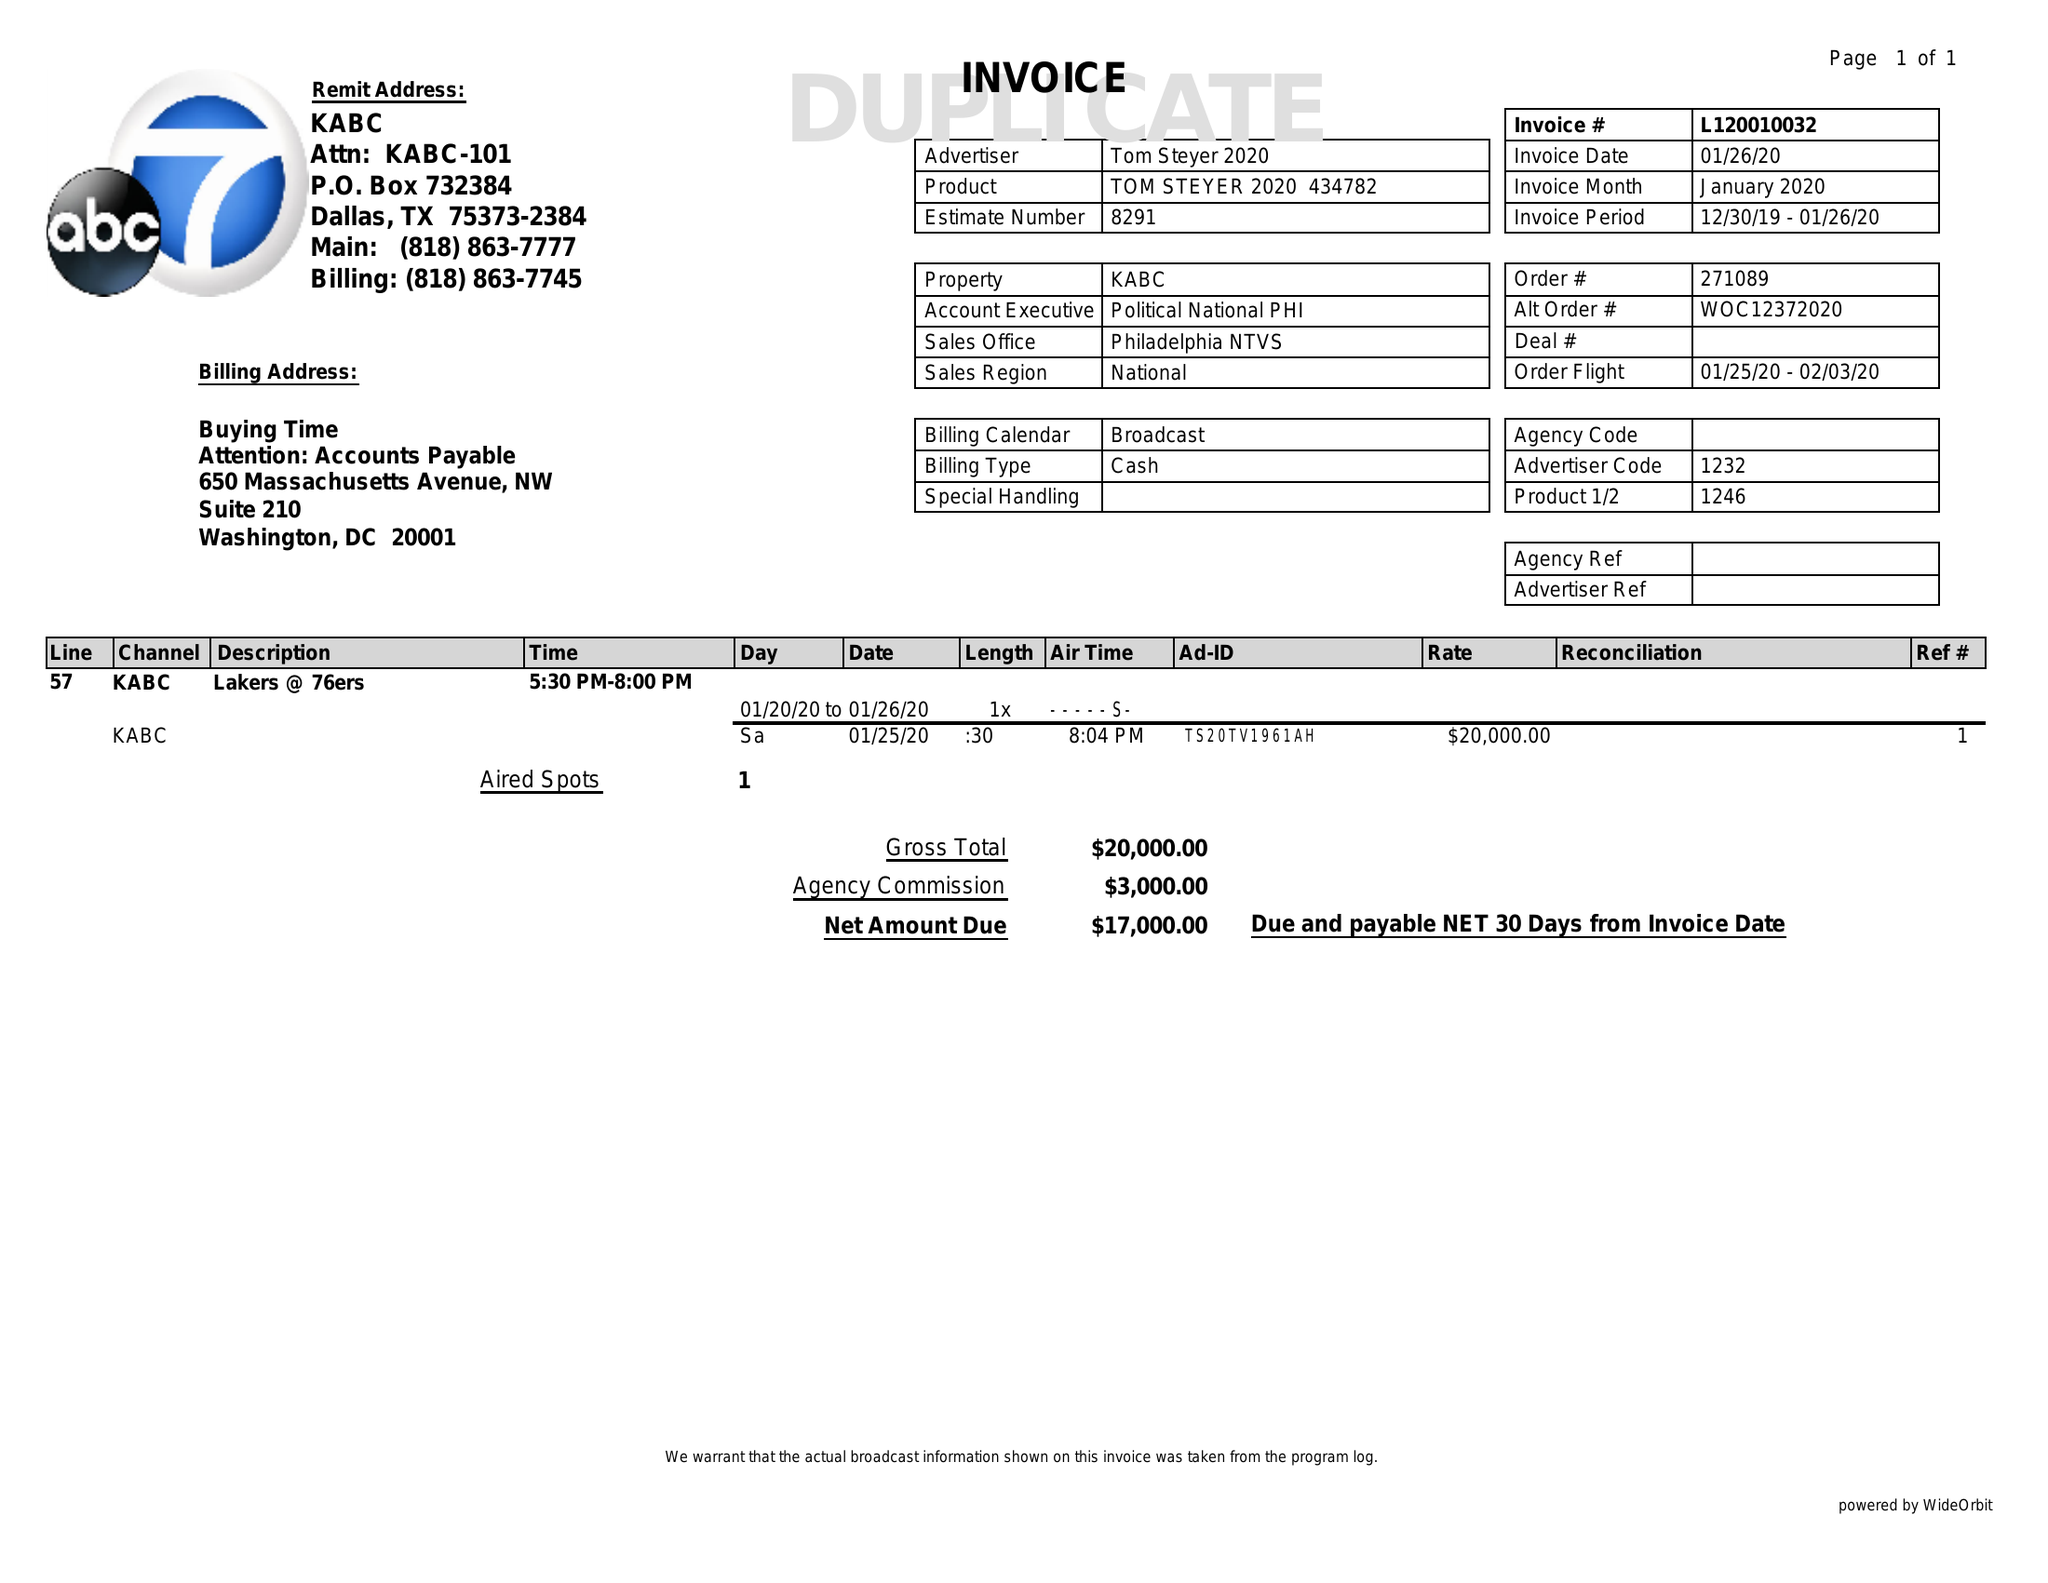What is the value for the advertiser?
Answer the question using a single word or phrase. TOM STEYER 2020 